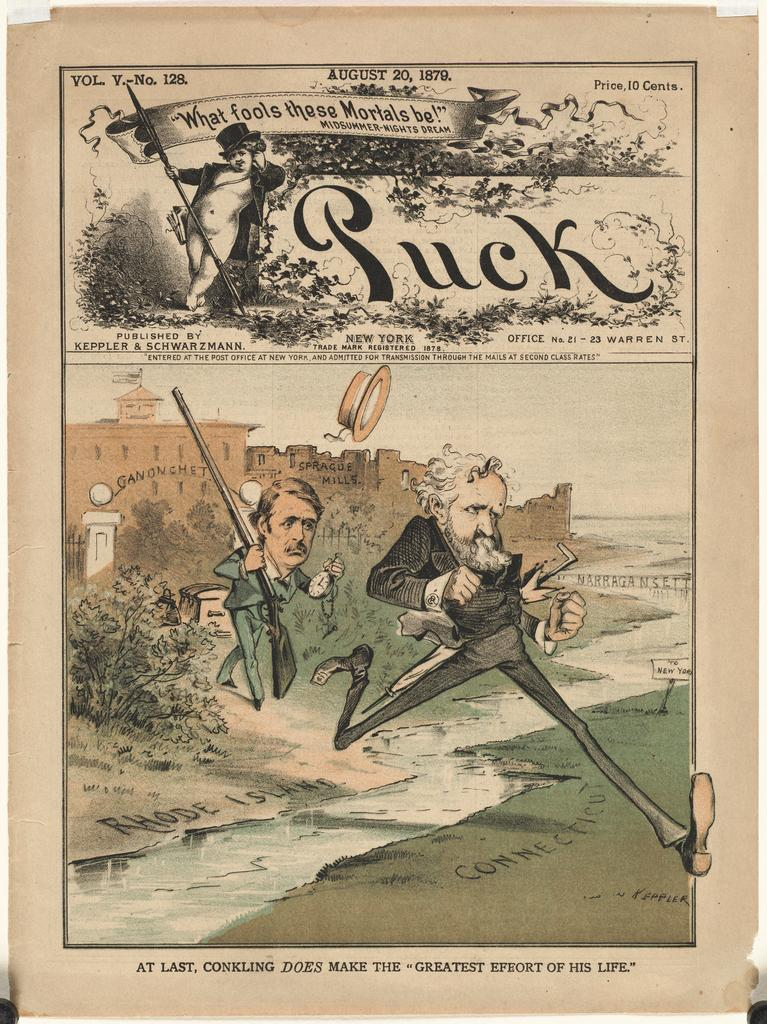Provide a one-sentence caption for the provided image. A political cartoon with the word Puck at the top. 